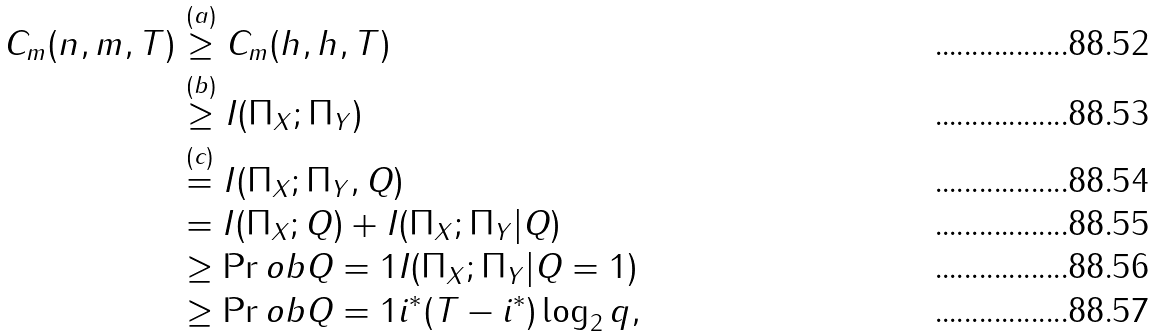<formula> <loc_0><loc_0><loc_500><loc_500>C _ { m } ( n , m , T ) & \stackrel { ( a ) } { \geq } C _ { m } ( h , h , T ) \\ & \stackrel { ( b ) } { \geq } I ( \Pi _ { X } ; \Pi _ { Y } ) \\ & \stackrel { ( c ) } { = } I ( \Pi _ { X } ; \Pi _ { Y } , Q ) \\ & = I ( \Pi _ { X } ; Q ) + I ( \Pi _ { X } ; \Pi _ { Y } | Q ) \\ & \geq \Pr o b { Q = 1 } I ( \Pi _ { X } ; \Pi _ { Y } | Q = 1 ) \\ & \geq \Pr o b { Q = 1 } i ^ { * } ( T - i ^ { * } ) \log _ { 2 } { q } ,</formula> 